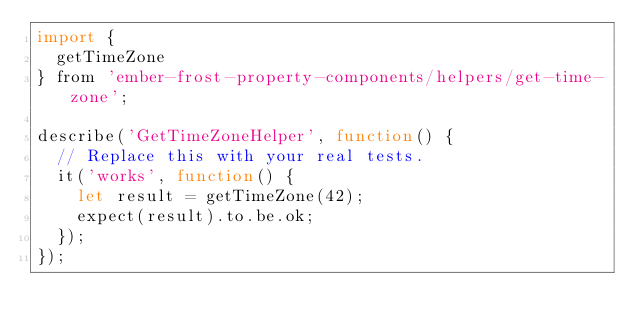Convert code to text. <code><loc_0><loc_0><loc_500><loc_500><_JavaScript_>import {
  getTimeZone
} from 'ember-frost-property-components/helpers/get-time-zone';

describe('GetTimeZoneHelper', function() {
  // Replace this with your real tests.
  it('works', function() {
    let result = getTimeZone(42);
    expect(result).to.be.ok;
  });
});
</code> 